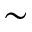Convert formula to latex. <formula><loc_0><loc_0><loc_500><loc_500>\sim</formula> 